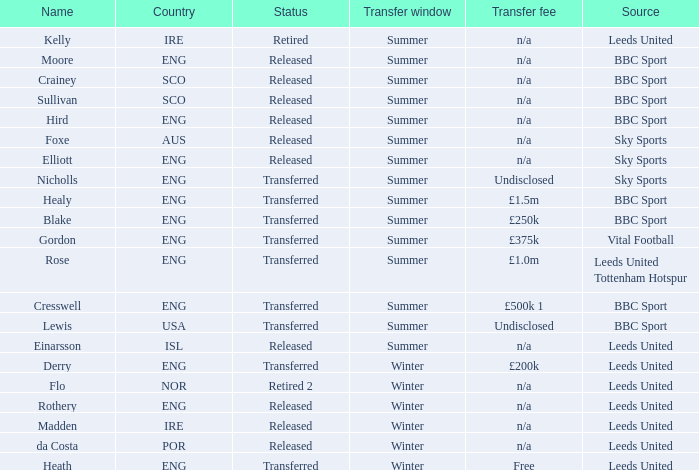What was the transfer fee for the summer transfer involving the SCO named Crainey? N/a. 